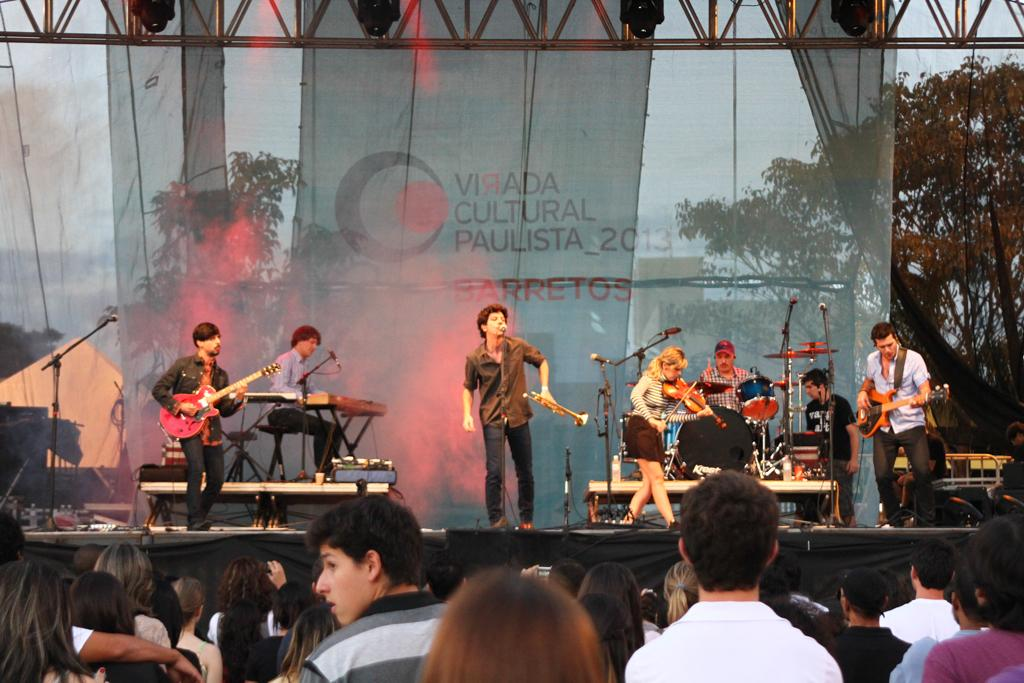What are the people in the image doing? There is a group of people playing musical instruments in the image, and another group of people is watching them. How many groups of people can be seen in the image? There are two groups of people in the image, one playing musical instruments and the other watching them. Can you see a snake slithering through the crowd in the image? No, there is no snake present in the image. 